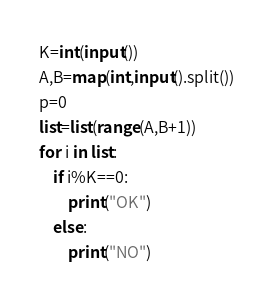<code> <loc_0><loc_0><loc_500><loc_500><_Python_>K=int(input())
A,B=map(int,input().split())
p=0
list=list(range(A,B+1))
for i in list:
    if i%K==0:
        print("OK")
    else:
        print("NO")</code> 